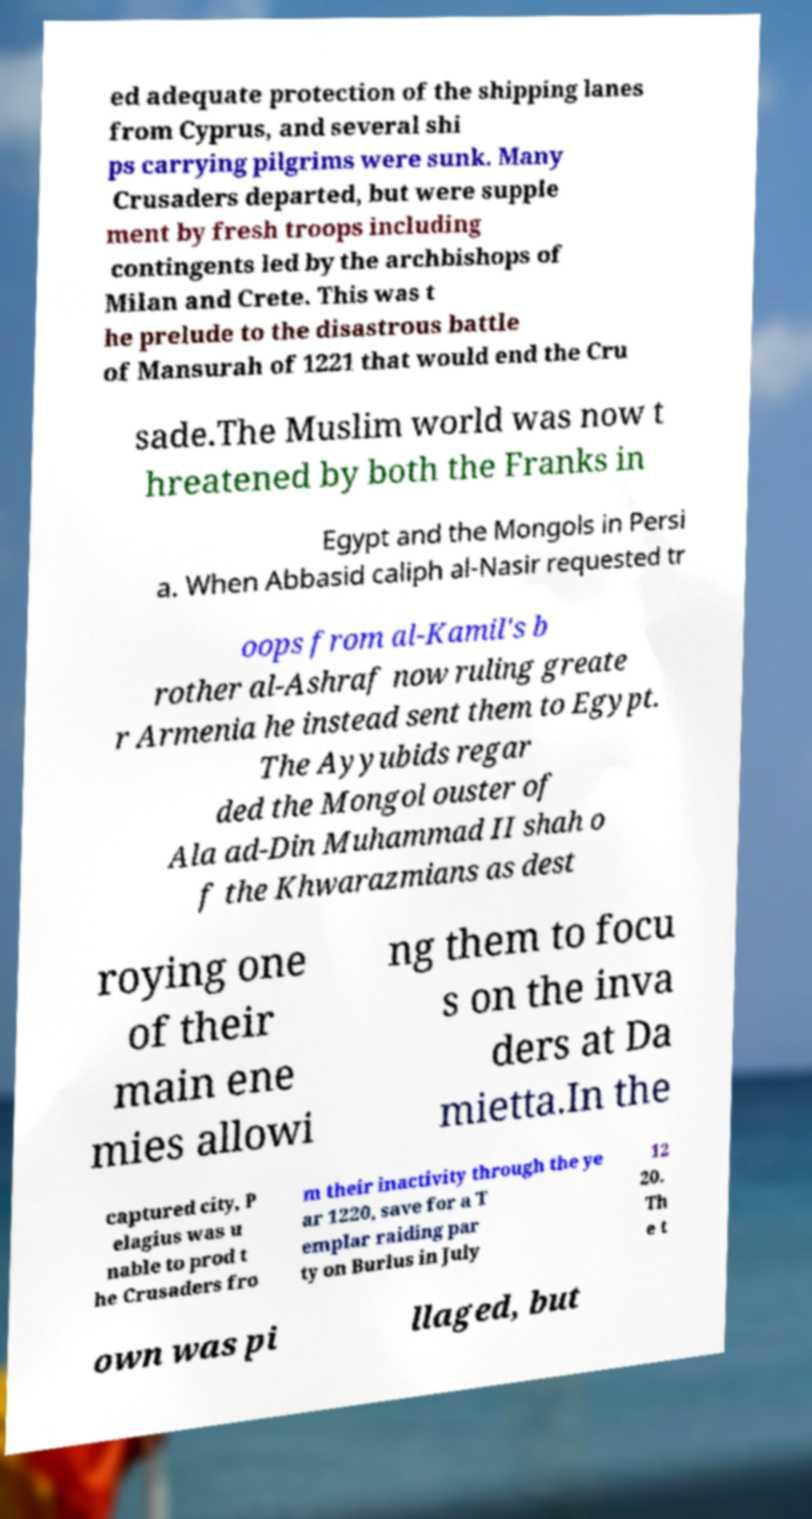What messages or text are displayed in this image? I need them in a readable, typed format. ed adequate protection of the shipping lanes from Cyprus, and several shi ps carrying pilgrims were sunk. Many Crusaders departed, but were supple ment by fresh troops including contingents led by the archbishops of Milan and Crete. This was t he prelude to the disastrous battle of Mansurah of 1221 that would end the Cru sade.The Muslim world was now t hreatened by both the Franks in Egypt and the Mongols in Persi a. When Abbasid caliph al-Nasir requested tr oops from al-Kamil's b rother al-Ashraf now ruling greate r Armenia he instead sent them to Egypt. The Ayyubids regar ded the Mongol ouster of Ala ad-Din Muhammad II shah o f the Khwarazmians as dest roying one of their main ene mies allowi ng them to focu s on the inva ders at Da mietta.In the captured city, P elagius was u nable to prod t he Crusaders fro m their inactivity through the ye ar 1220, save for a T emplar raiding par ty on Burlus in July 12 20. Th e t own was pi llaged, but 